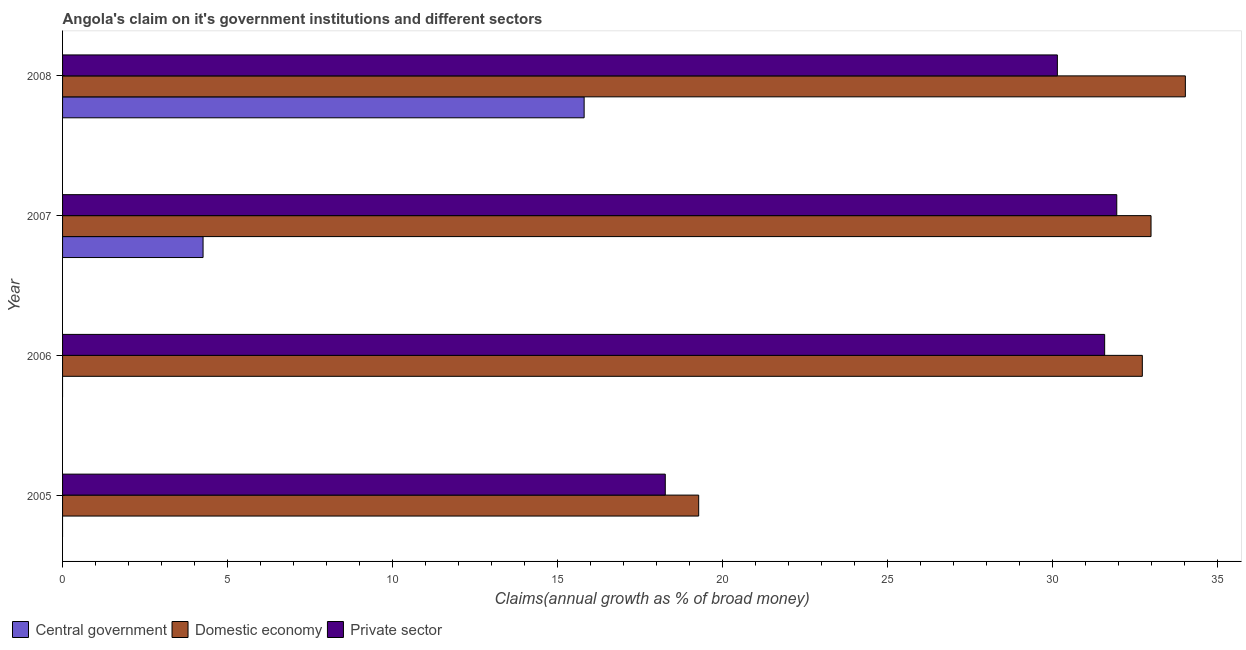How many groups of bars are there?
Ensure brevity in your answer.  4. Are the number of bars on each tick of the Y-axis equal?
Your response must be concise. No. How many bars are there on the 3rd tick from the top?
Offer a terse response. 2. How many bars are there on the 1st tick from the bottom?
Make the answer very short. 2. In how many cases, is the number of bars for a given year not equal to the number of legend labels?
Offer a very short reply. 2. What is the percentage of claim on the private sector in 2008?
Your response must be concise. 30.14. Across all years, what is the maximum percentage of claim on the central government?
Provide a short and direct response. 15.8. In which year was the percentage of claim on the central government maximum?
Give a very brief answer. 2008. What is the total percentage of claim on the private sector in the graph?
Your answer should be very brief. 111.91. What is the difference between the percentage of claim on the private sector in 2005 and that in 2008?
Provide a short and direct response. -11.88. What is the difference between the percentage of claim on the private sector in 2006 and the percentage of claim on the central government in 2005?
Offer a terse response. 31.57. What is the average percentage of claim on the central government per year?
Offer a very short reply. 5.01. In the year 2008, what is the difference between the percentage of claim on the central government and percentage of claim on the domestic economy?
Your answer should be compact. -18.22. What is the ratio of the percentage of claim on the private sector in 2006 to that in 2007?
Provide a succinct answer. 0.99. Is the percentage of claim on the private sector in 2005 less than that in 2006?
Make the answer very short. Yes. Is the difference between the percentage of claim on the domestic economy in 2005 and 2007 greater than the difference between the percentage of claim on the private sector in 2005 and 2007?
Provide a short and direct response. No. What is the difference between the highest and the second highest percentage of claim on the private sector?
Offer a very short reply. 0.37. What is the difference between the highest and the lowest percentage of claim on the central government?
Keep it short and to the point. 15.8. How many bars are there?
Make the answer very short. 10. Are all the bars in the graph horizontal?
Provide a short and direct response. Yes. How many years are there in the graph?
Keep it short and to the point. 4. What is the difference between two consecutive major ticks on the X-axis?
Your answer should be very brief. 5. Are the values on the major ticks of X-axis written in scientific E-notation?
Keep it short and to the point. No. Does the graph contain any zero values?
Your answer should be compact. Yes. Does the graph contain grids?
Keep it short and to the point. No. How many legend labels are there?
Your answer should be compact. 3. What is the title of the graph?
Provide a succinct answer. Angola's claim on it's government institutions and different sectors. Does "Resident buildings and public services" appear as one of the legend labels in the graph?
Your answer should be very brief. No. What is the label or title of the X-axis?
Offer a very short reply. Claims(annual growth as % of broad money). What is the label or title of the Y-axis?
Provide a succinct answer. Year. What is the Claims(annual growth as % of broad money) in Domestic economy in 2005?
Ensure brevity in your answer.  19.27. What is the Claims(annual growth as % of broad money) in Private sector in 2005?
Offer a very short reply. 18.26. What is the Claims(annual growth as % of broad money) in Central government in 2006?
Provide a short and direct response. 0. What is the Claims(annual growth as % of broad money) in Domestic economy in 2006?
Make the answer very short. 32.71. What is the Claims(annual growth as % of broad money) in Private sector in 2006?
Your response must be concise. 31.57. What is the Claims(annual growth as % of broad money) in Central government in 2007?
Your response must be concise. 4.26. What is the Claims(annual growth as % of broad money) of Domestic economy in 2007?
Your response must be concise. 32.98. What is the Claims(annual growth as % of broad money) in Private sector in 2007?
Make the answer very short. 31.94. What is the Claims(annual growth as % of broad money) of Central government in 2008?
Make the answer very short. 15.8. What is the Claims(annual growth as % of broad money) of Domestic economy in 2008?
Your response must be concise. 34.02. What is the Claims(annual growth as % of broad money) in Private sector in 2008?
Ensure brevity in your answer.  30.14. Across all years, what is the maximum Claims(annual growth as % of broad money) in Central government?
Keep it short and to the point. 15.8. Across all years, what is the maximum Claims(annual growth as % of broad money) of Domestic economy?
Make the answer very short. 34.02. Across all years, what is the maximum Claims(annual growth as % of broad money) in Private sector?
Your answer should be compact. 31.94. Across all years, what is the minimum Claims(annual growth as % of broad money) of Central government?
Give a very brief answer. 0. Across all years, what is the minimum Claims(annual growth as % of broad money) in Domestic economy?
Make the answer very short. 19.27. Across all years, what is the minimum Claims(annual growth as % of broad money) of Private sector?
Keep it short and to the point. 18.26. What is the total Claims(annual growth as % of broad money) of Central government in the graph?
Give a very brief answer. 20.06. What is the total Claims(annual growth as % of broad money) of Domestic economy in the graph?
Give a very brief answer. 118.98. What is the total Claims(annual growth as % of broad money) in Private sector in the graph?
Make the answer very short. 111.91. What is the difference between the Claims(annual growth as % of broad money) of Domestic economy in 2005 and that in 2006?
Keep it short and to the point. -13.44. What is the difference between the Claims(annual growth as % of broad money) of Private sector in 2005 and that in 2006?
Keep it short and to the point. -13.31. What is the difference between the Claims(annual growth as % of broad money) of Domestic economy in 2005 and that in 2007?
Keep it short and to the point. -13.71. What is the difference between the Claims(annual growth as % of broad money) of Private sector in 2005 and that in 2007?
Offer a terse response. -13.68. What is the difference between the Claims(annual growth as % of broad money) in Domestic economy in 2005 and that in 2008?
Your answer should be very brief. -14.74. What is the difference between the Claims(annual growth as % of broad money) in Private sector in 2005 and that in 2008?
Give a very brief answer. -11.88. What is the difference between the Claims(annual growth as % of broad money) in Domestic economy in 2006 and that in 2007?
Offer a terse response. -0.26. What is the difference between the Claims(annual growth as % of broad money) of Private sector in 2006 and that in 2007?
Ensure brevity in your answer.  -0.37. What is the difference between the Claims(annual growth as % of broad money) in Domestic economy in 2006 and that in 2008?
Ensure brevity in your answer.  -1.3. What is the difference between the Claims(annual growth as % of broad money) in Private sector in 2006 and that in 2008?
Ensure brevity in your answer.  1.43. What is the difference between the Claims(annual growth as % of broad money) in Central government in 2007 and that in 2008?
Ensure brevity in your answer.  -11.55. What is the difference between the Claims(annual growth as % of broad money) of Domestic economy in 2007 and that in 2008?
Your answer should be very brief. -1.04. What is the difference between the Claims(annual growth as % of broad money) in Private sector in 2007 and that in 2008?
Provide a succinct answer. 1.8. What is the difference between the Claims(annual growth as % of broad money) in Domestic economy in 2005 and the Claims(annual growth as % of broad money) in Private sector in 2006?
Provide a short and direct response. -12.3. What is the difference between the Claims(annual growth as % of broad money) of Domestic economy in 2005 and the Claims(annual growth as % of broad money) of Private sector in 2007?
Your answer should be compact. -12.67. What is the difference between the Claims(annual growth as % of broad money) in Domestic economy in 2005 and the Claims(annual growth as % of broad money) in Private sector in 2008?
Give a very brief answer. -10.87. What is the difference between the Claims(annual growth as % of broad money) in Domestic economy in 2006 and the Claims(annual growth as % of broad money) in Private sector in 2007?
Offer a terse response. 0.77. What is the difference between the Claims(annual growth as % of broad money) in Domestic economy in 2006 and the Claims(annual growth as % of broad money) in Private sector in 2008?
Provide a short and direct response. 2.57. What is the difference between the Claims(annual growth as % of broad money) of Central government in 2007 and the Claims(annual growth as % of broad money) of Domestic economy in 2008?
Make the answer very short. -29.76. What is the difference between the Claims(annual growth as % of broad money) in Central government in 2007 and the Claims(annual growth as % of broad money) in Private sector in 2008?
Ensure brevity in your answer.  -25.88. What is the difference between the Claims(annual growth as % of broad money) in Domestic economy in 2007 and the Claims(annual growth as % of broad money) in Private sector in 2008?
Your response must be concise. 2.84. What is the average Claims(annual growth as % of broad money) in Central government per year?
Make the answer very short. 5.01. What is the average Claims(annual growth as % of broad money) of Domestic economy per year?
Offer a terse response. 29.75. What is the average Claims(annual growth as % of broad money) of Private sector per year?
Your response must be concise. 27.98. In the year 2005, what is the difference between the Claims(annual growth as % of broad money) in Domestic economy and Claims(annual growth as % of broad money) in Private sector?
Your response must be concise. 1.01. In the year 2006, what is the difference between the Claims(annual growth as % of broad money) in Domestic economy and Claims(annual growth as % of broad money) in Private sector?
Provide a succinct answer. 1.14. In the year 2007, what is the difference between the Claims(annual growth as % of broad money) in Central government and Claims(annual growth as % of broad money) in Domestic economy?
Your answer should be compact. -28.72. In the year 2007, what is the difference between the Claims(annual growth as % of broad money) in Central government and Claims(annual growth as % of broad money) in Private sector?
Provide a short and direct response. -27.68. In the year 2007, what is the difference between the Claims(annual growth as % of broad money) of Domestic economy and Claims(annual growth as % of broad money) of Private sector?
Ensure brevity in your answer.  1.04. In the year 2008, what is the difference between the Claims(annual growth as % of broad money) of Central government and Claims(annual growth as % of broad money) of Domestic economy?
Your answer should be very brief. -18.22. In the year 2008, what is the difference between the Claims(annual growth as % of broad money) in Central government and Claims(annual growth as % of broad money) in Private sector?
Provide a short and direct response. -14.34. In the year 2008, what is the difference between the Claims(annual growth as % of broad money) in Domestic economy and Claims(annual growth as % of broad money) in Private sector?
Your answer should be very brief. 3.88. What is the ratio of the Claims(annual growth as % of broad money) of Domestic economy in 2005 to that in 2006?
Offer a very short reply. 0.59. What is the ratio of the Claims(annual growth as % of broad money) of Private sector in 2005 to that in 2006?
Offer a terse response. 0.58. What is the ratio of the Claims(annual growth as % of broad money) of Domestic economy in 2005 to that in 2007?
Keep it short and to the point. 0.58. What is the ratio of the Claims(annual growth as % of broad money) of Private sector in 2005 to that in 2007?
Offer a terse response. 0.57. What is the ratio of the Claims(annual growth as % of broad money) in Domestic economy in 2005 to that in 2008?
Your answer should be compact. 0.57. What is the ratio of the Claims(annual growth as % of broad money) in Private sector in 2005 to that in 2008?
Your response must be concise. 0.61. What is the ratio of the Claims(annual growth as % of broad money) of Domestic economy in 2006 to that in 2008?
Ensure brevity in your answer.  0.96. What is the ratio of the Claims(annual growth as % of broad money) in Private sector in 2006 to that in 2008?
Provide a short and direct response. 1.05. What is the ratio of the Claims(annual growth as % of broad money) in Central government in 2007 to that in 2008?
Offer a terse response. 0.27. What is the ratio of the Claims(annual growth as % of broad money) in Domestic economy in 2007 to that in 2008?
Ensure brevity in your answer.  0.97. What is the ratio of the Claims(annual growth as % of broad money) of Private sector in 2007 to that in 2008?
Ensure brevity in your answer.  1.06. What is the difference between the highest and the second highest Claims(annual growth as % of broad money) of Domestic economy?
Your answer should be very brief. 1.04. What is the difference between the highest and the second highest Claims(annual growth as % of broad money) in Private sector?
Your answer should be very brief. 0.37. What is the difference between the highest and the lowest Claims(annual growth as % of broad money) of Central government?
Offer a very short reply. 15.8. What is the difference between the highest and the lowest Claims(annual growth as % of broad money) in Domestic economy?
Provide a succinct answer. 14.74. What is the difference between the highest and the lowest Claims(annual growth as % of broad money) of Private sector?
Your answer should be compact. 13.68. 